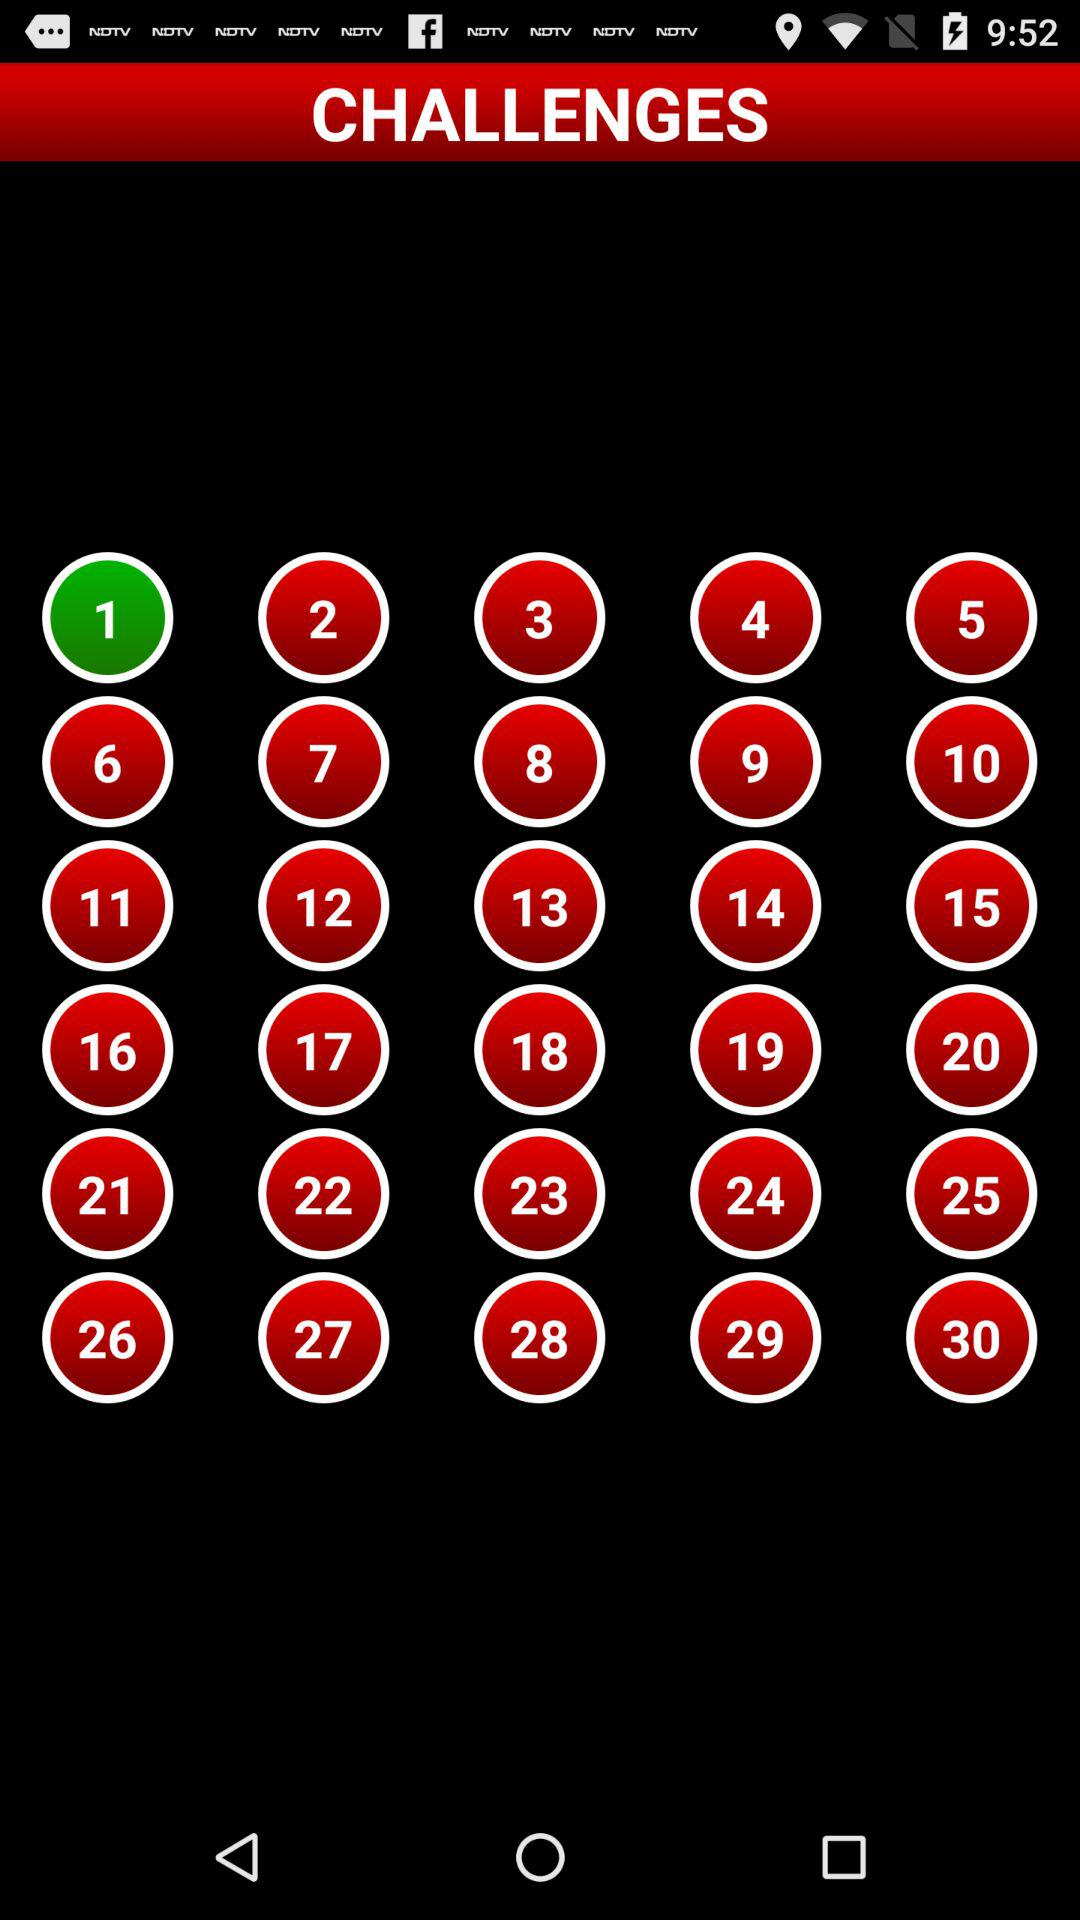Which challenge is highlighted? The highlighted challenge is 1. 